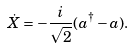<formula> <loc_0><loc_0><loc_500><loc_500>\dot { X } = - \frac { i } { \sqrt { 2 } } ( a ^ { \dagger } - a ) .</formula> 